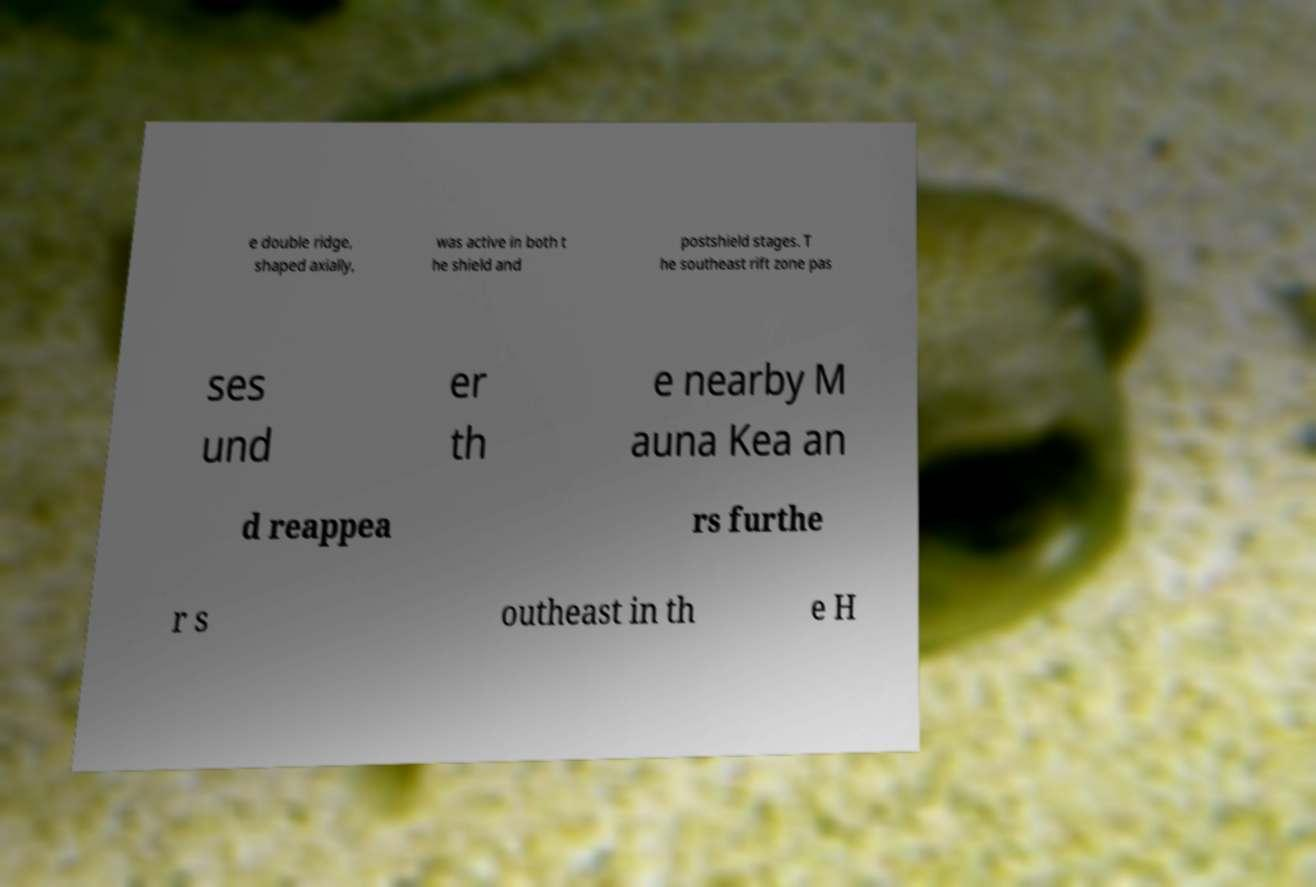Could you extract and type out the text from this image? e double ridge, shaped axially, was active in both t he shield and postshield stages. T he southeast rift zone pas ses und er th e nearby M auna Kea an d reappea rs furthe r s outheast in th e H 